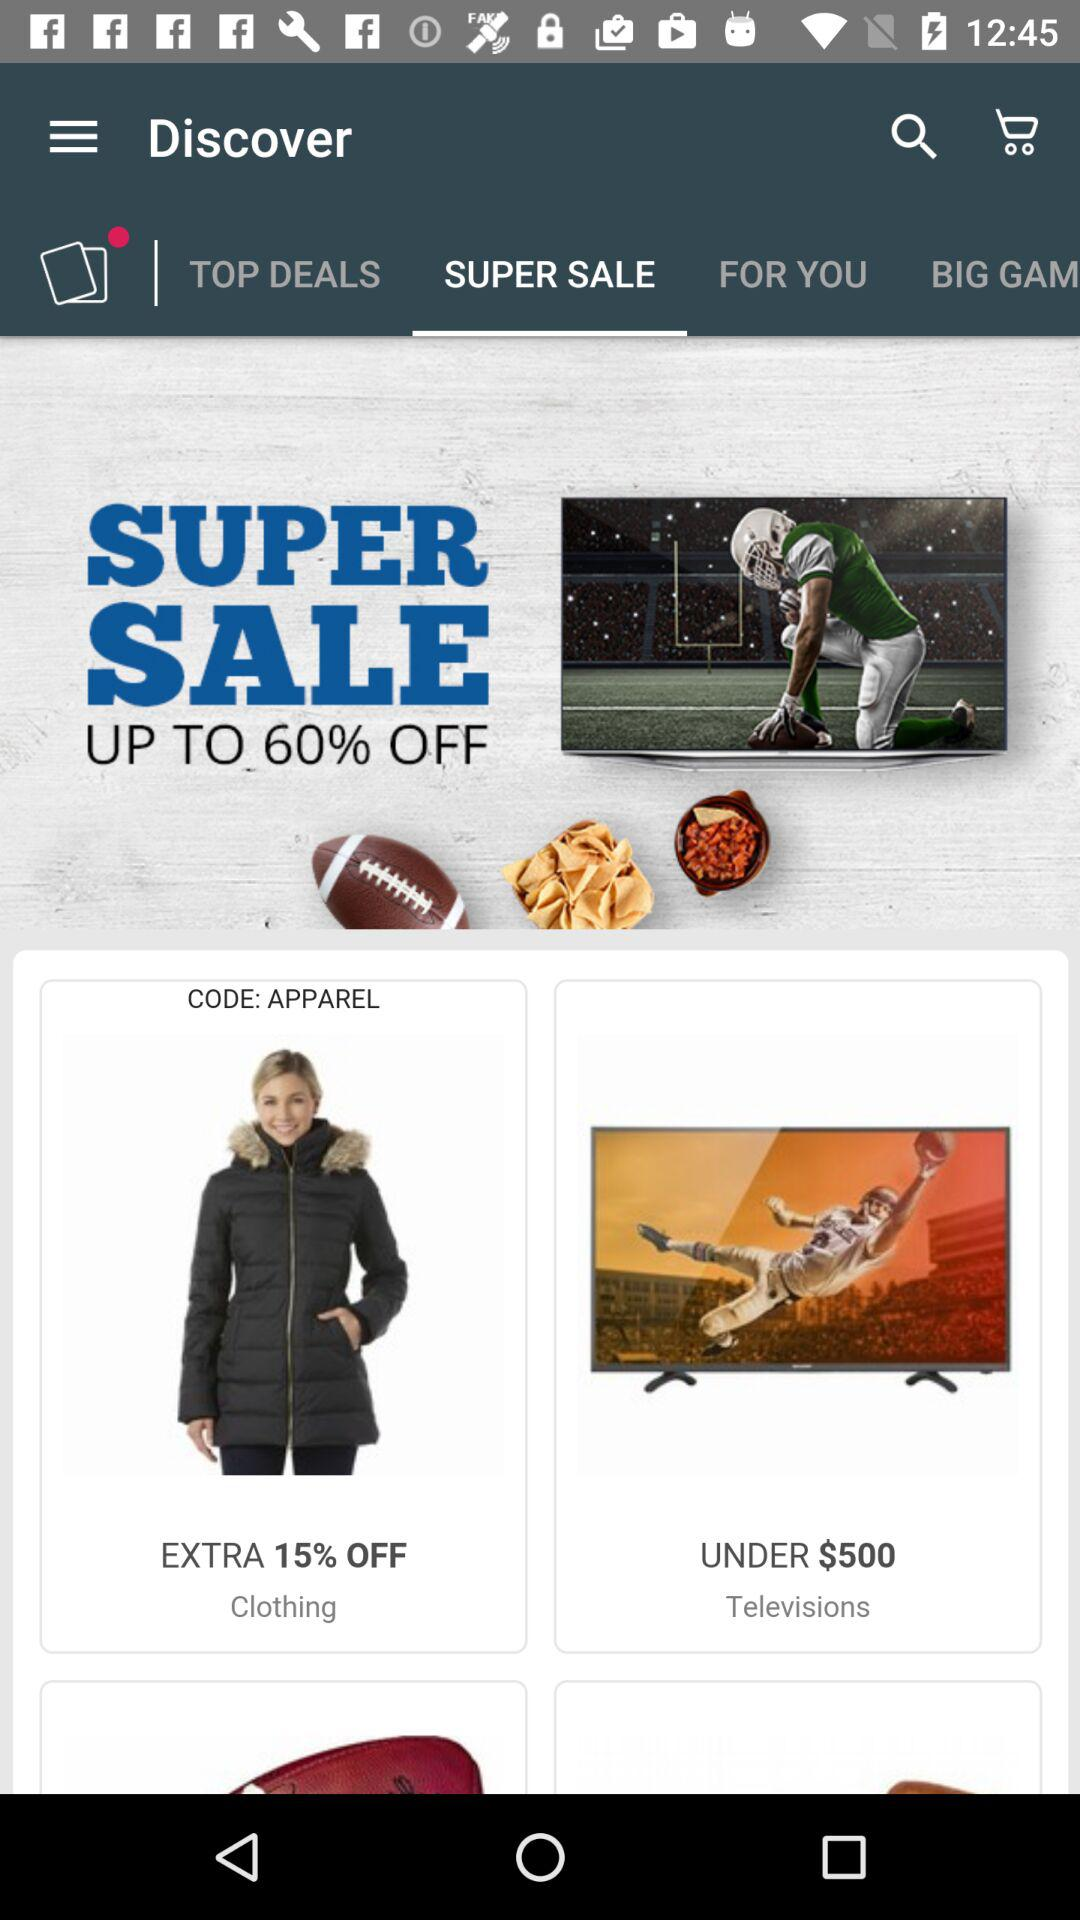How much is the discount on the super sale? The discount is "UP TO 60% OFF". 